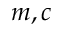Convert formula to latex. <formula><loc_0><loc_0><loc_500><loc_500>m , c</formula> 